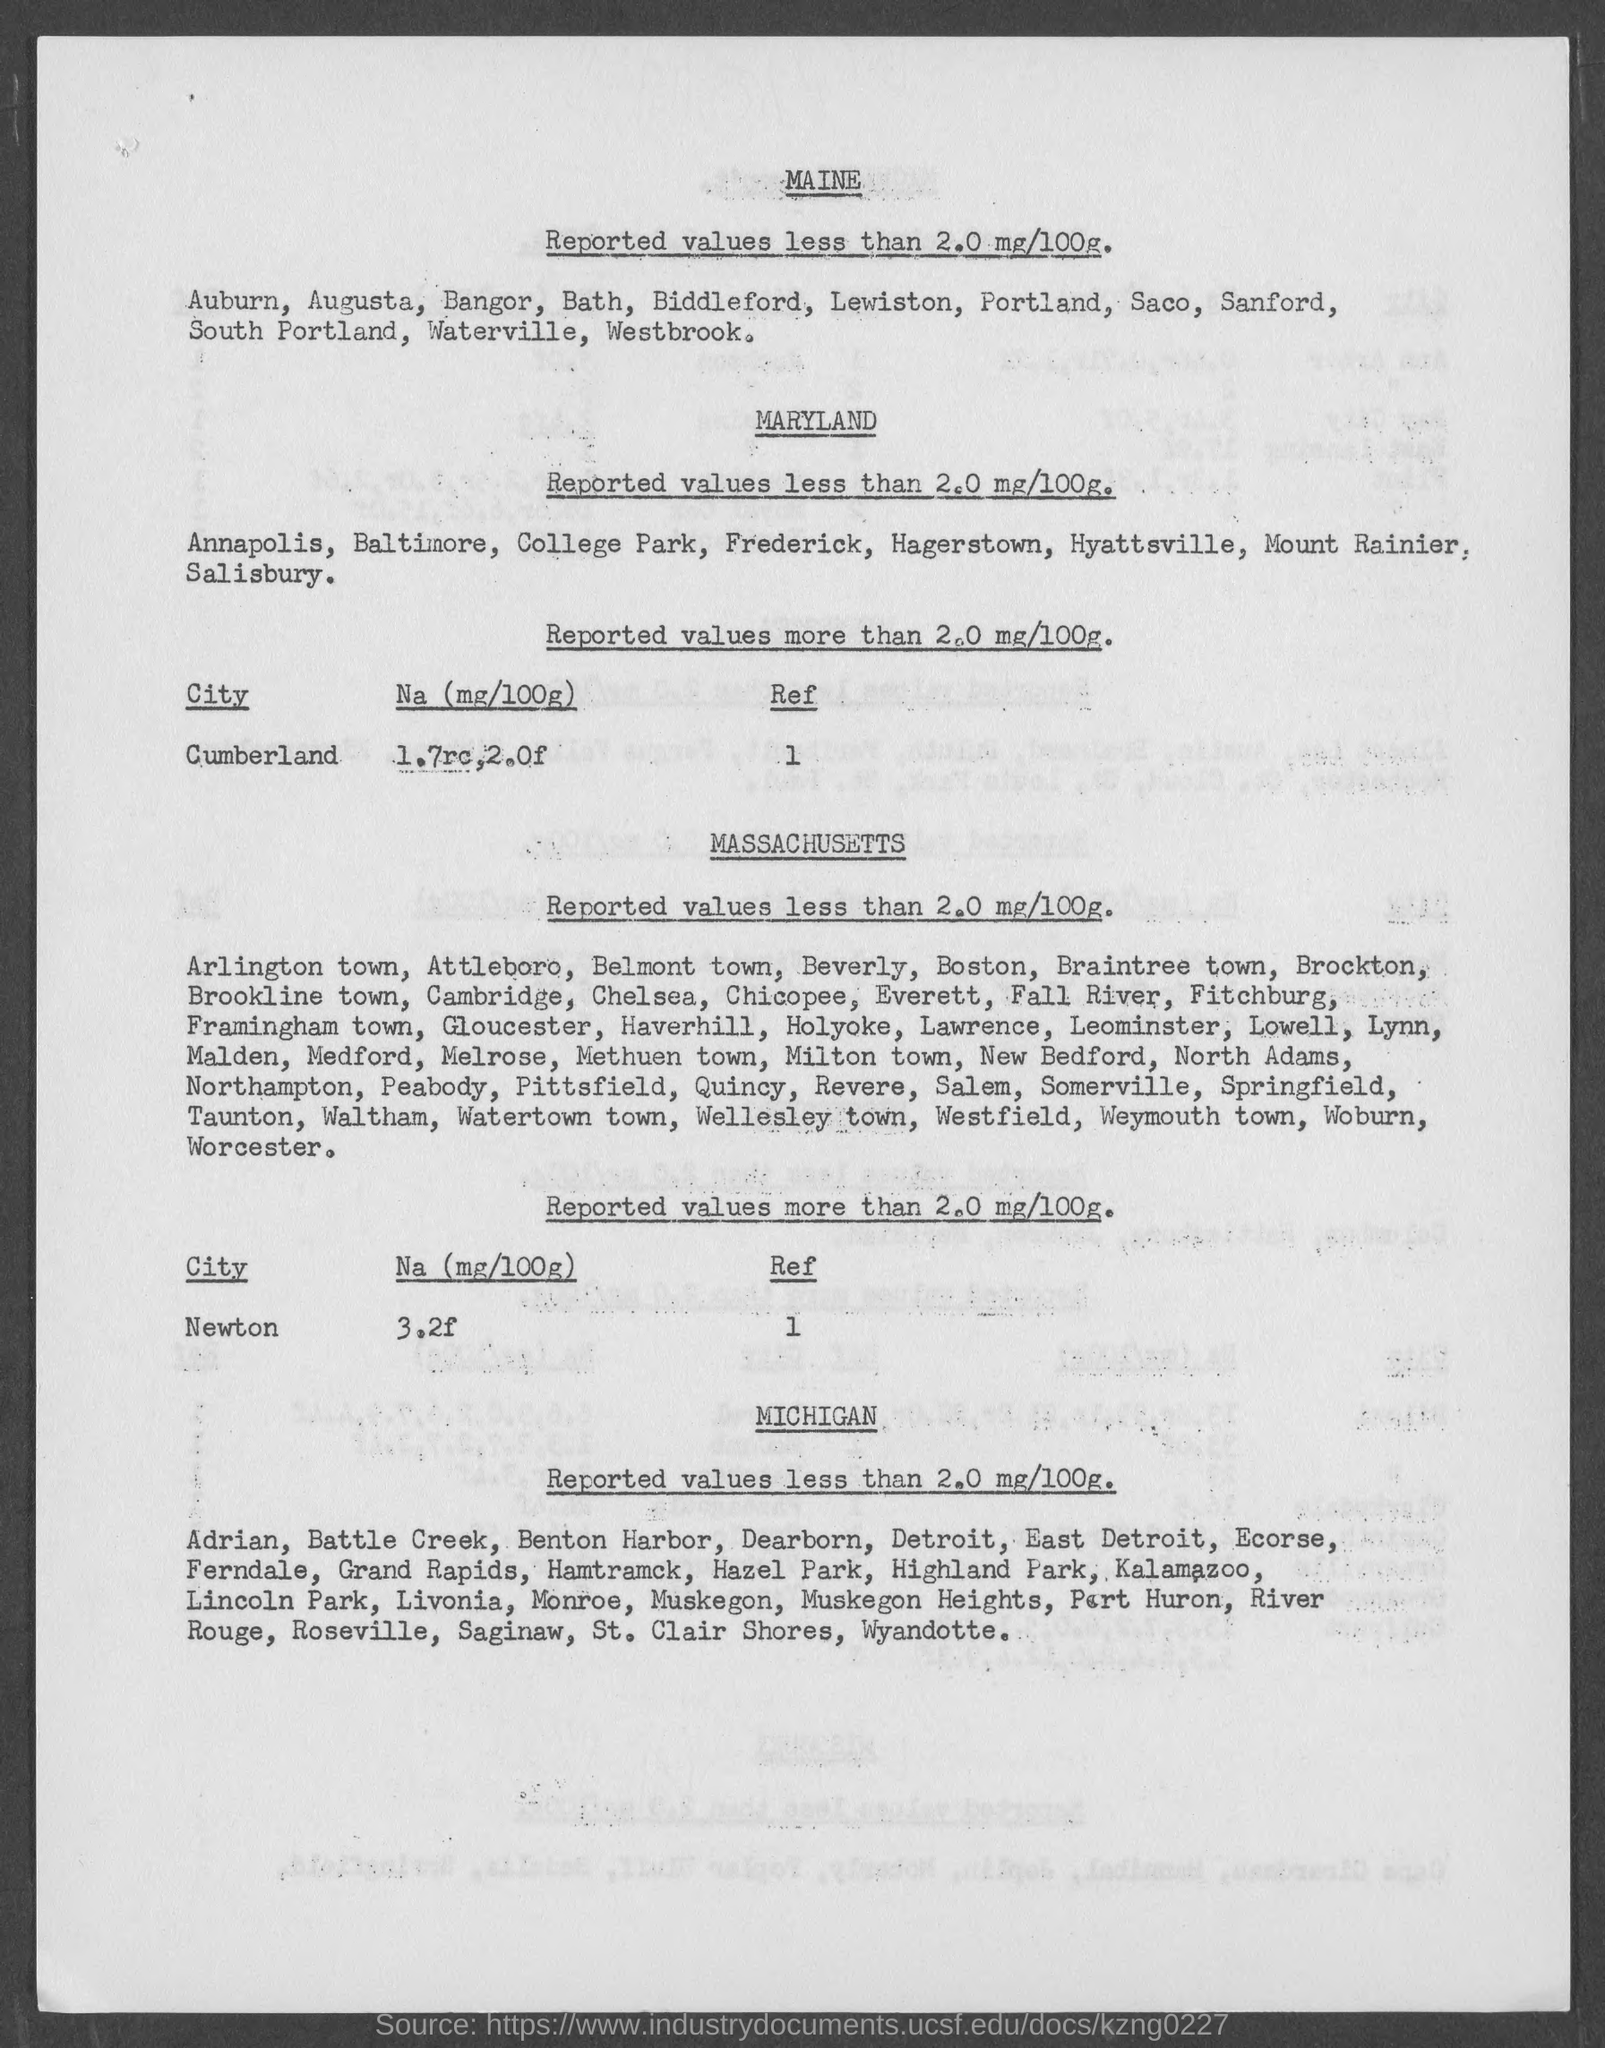Point out several critical features in this image. The Na (mg/100g) in Newton is 3.2f. 